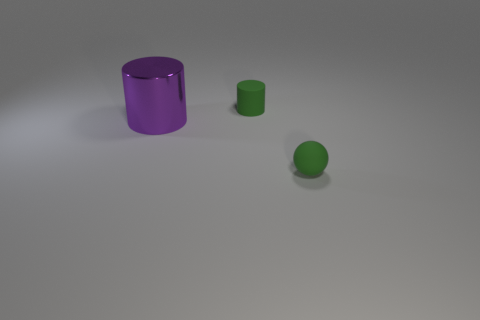What number of metal things are small red spheres or green cylinders?
Provide a succinct answer. 0. What is the tiny object behind the tiny green ball on the right side of the large purple object made of?
Ensure brevity in your answer.  Rubber. Is the number of purple metal cylinders to the right of the large purple cylinder greater than the number of tiny blue rubber cubes?
Offer a very short reply. No. Is there a cylinder made of the same material as the big object?
Your answer should be compact. No. Do the small green thing that is right of the small green cylinder and the purple shiny thing have the same shape?
Make the answer very short. No. There is a matte thing in front of the tiny green matte object that is behind the big purple cylinder; what number of big purple cylinders are on the right side of it?
Offer a terse response. 0. Is the number of green matte cylinders behind the purple cylinder less than the number of cylinders behind the ball?
Offer a very short reply. Yes. The purple metallic cylinder has what size?
Give a very brief answer. Large. How many objects have the same size as the ball?
Your response must be concise. 1. Do the metal cylinder and the tiny rubber cylinder have the same color?
Give a very brief answer. No. 